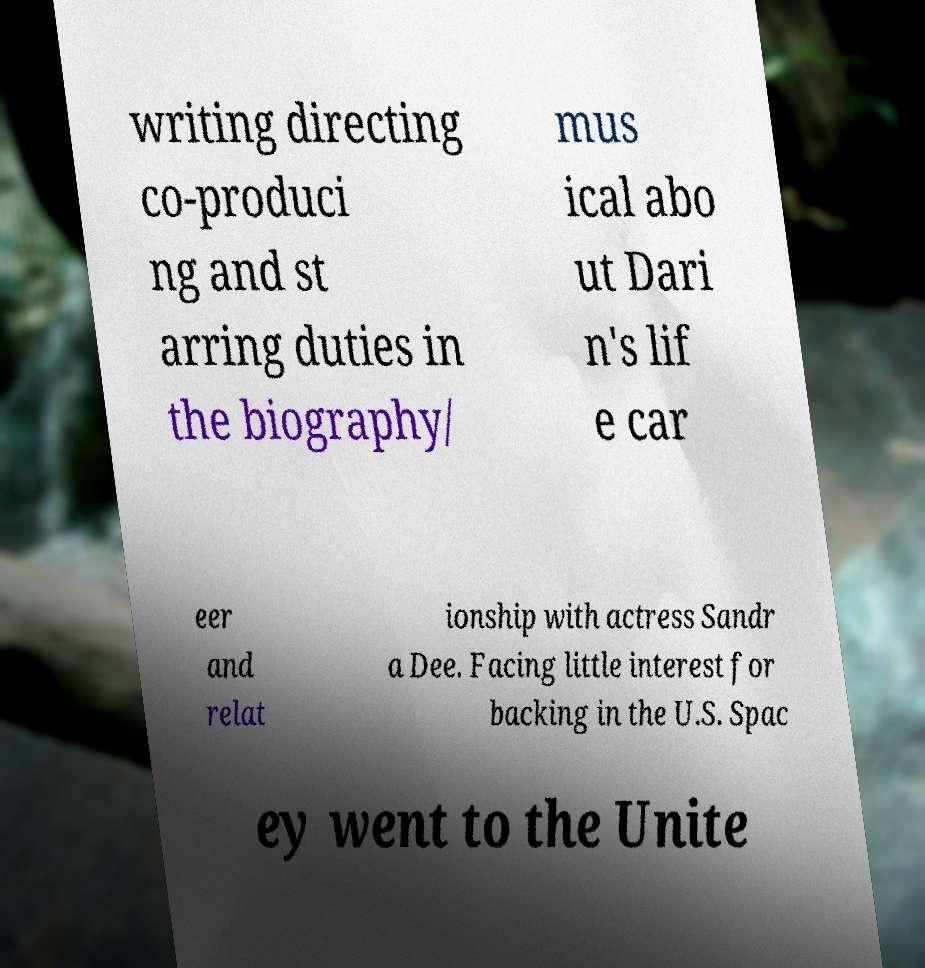There's text embedded in this image that I need extracted. Can you transcribe it verbatim? writing directing co-produci ng and st arring duties in the biography/ mus ical abo ut Dari n's lif e car eer and relat ionship with actress Sandr a Dee. Facing little interest for backing in the U.S. Spac ey went to the Unite 